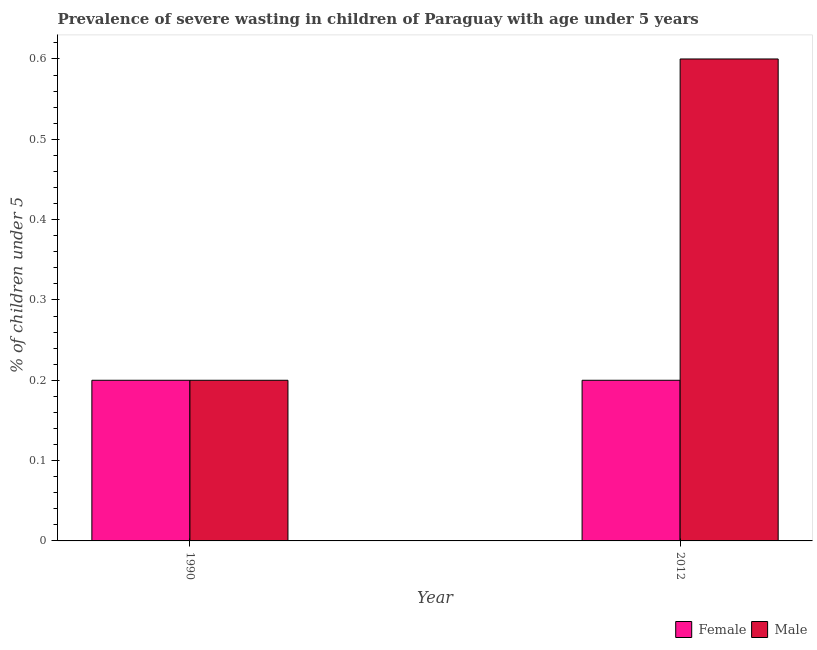How many groups of bars are there?
Your response must be concise. 2. Are the number of bars per tick equal to the number of legend labels?
Give a very brief answer. Yes. Are the number of bars on each tick of the X-axis equal?
Your response must be concise. Yes. How many bars are there on the 2nd tick from the right?
Ensure brevity in your answer.  2. In how many cases, is the number of bars for a given year not equal to the number of legend labels?
Give a very brief answer. 0. What is the percentage of undernourished male children in 2012?
Provide a succinct answer. 0.6. Across all years, what is the maximum percentage of undernourished female children?
Your answer should be compact. 0.2. Across all years, what is the minimum percentage of undernourished male children?
Your answer should be very brief. 0.2. In which year was the percentage of undernourished female children maximum?
Your answer should be compact. 1990. What is the total percentage of undernourished male children in the graph?
Make the answer very short. 0.8. What is the average percentage of undernourished male children per year?
Your answer should be very brief. 0.4. In how many years, is the percentage of undernourished female children greater than 0.1 %?
Make the answer very short. 2. How many bars are there?
Give a very brief answer. 4. Are all the bars in the graph horizontal?
Ensure brevity in your answer.  No. Does the graph contain grids?
Your answer should be very brief. No. Where does the legend appear in the graph?
Offer a terse response. Bottom right. How many legend labels are there?
Provide a short and direct response. 2. What is the title of the graph?
Give a very brief answer. Prevalence of severe wasting in children of Paraguay with age under 5 years. What is the label or title of the X-axis?
Offer a very short reply. Year. What is the label or title of the Y-axis?
Offer a terse response.  % of children under 5. What is the  % of children under 5 in Female in 1990?
Give a very brief answer. 0.2. What is the  % of children under 5 of Male in 1990?
Provide a short and direct response. 0.2. What is the  % of children under 5 of Female in 2012?
Your answer should be very brief. 0.2. What is the  % of children under 5 of Male in 2012?
Make the answer very short. 0.6. Across all years, what is the maximum  % of children under 5 of Female?
Make the answer very short. 0.2. Across all years, what is the maximum  % of children under 5 in Male?
Your answer should be very brief. 0.6. Across all years, what is the minimum  % of children under 5 in Female?
Provide a short and direct response. 0.2. Across all years, what is the minimum  % of children under 5 of Male?
Your answer should be very brief. 0.2. What is the total  % of children under 5 in Female in the graph?
Your answer should be compact. 0.4. What is the total  % of children under 5 of Male in the graph?
Your answer should be very brief. 0.8. What is the difference between the  % of children under 5 of Female in 1990 and the  % of children under 5 of Male in 2012?
Provide a succinct answer. -0.4. What is the average  % of children under 5 in Male per year?
Keep it short and to the point. 0.4. In the year 2012, what is the difference between the  % of children under 5 in Female and  % of children under 5 in Male?
Your answer should be very brief. -0.4. What is the difference between the highest and the second highest  % of children under 5 in Male?
Your answer should be very brief. 0.4. What is the difference between the highest and the lowest  % of children under 5 of Male?
Ensure brevity in your answer.  0.4. 